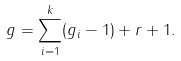Convert formula to latex. <formula><loc_0><loc_0><loc_500><loc_500>g = \sum _ { i = 1 } ^ { k } ( g _ { i } - 1 ) + r + 1 .</formula> 